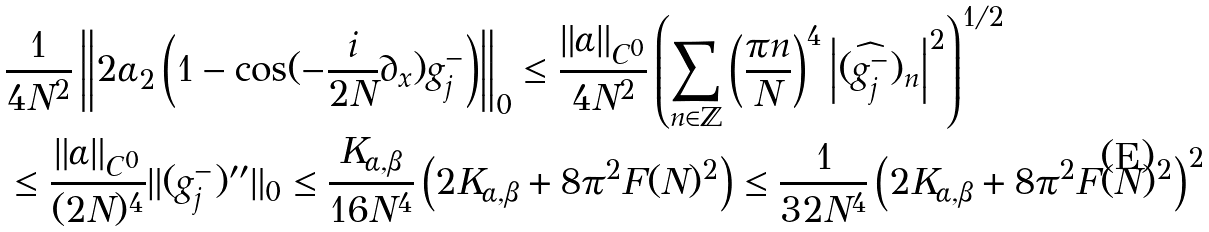<formula> <loc_0><loc_0><loc_500><loc_500>& \frac { 1 } { 4 N ^ { 2 } } \left \| 2 \alpha _ { 2 } \left ( 1 - \cos ( - \frac { i } { 2 N } \partial _ { x } ) g ^ { - } _ { j } \right ) \right \| _ { 0 } \leq \frac { \| \alpha \| _ { C ^ { 0 } } } { 4 N ^ { 2 } } \left ( \sum _ { n \in { \mathbb { Z } } } \left ( \frac { \pi n } { N } \right ) ^ { 4 } \left | ( \widehat { g ^ { - } _ { j } } ) _ { n } \right | ^ { 2 } \right ) ^ { 1 / 2 } \\ & \leq \frac { \| \alpha \| _ { C ^ { 0 } } } { ( 2 N ) ^ { 4 } } \| ( g ^ { - } _ { j } ) ^ { \prime \prime } \| _ { 0 } \leq \frac { K _ { \alpha , \beta } } { 1 6 N ^ { 4 } } \left ( 2 K _ { \alpha , \beta } + 8 \pi ^ { 2 } F ( N ) ^ { 2 } \right ) \leq \frac { 1 } { 3 2 N ^ { 4 } } \left ( 2 K _ { \alpha , \beta } + 8 \pi ^ { 2 } F ( N ) ^ { 2 } \right ) ^ { 2 }</formula> 